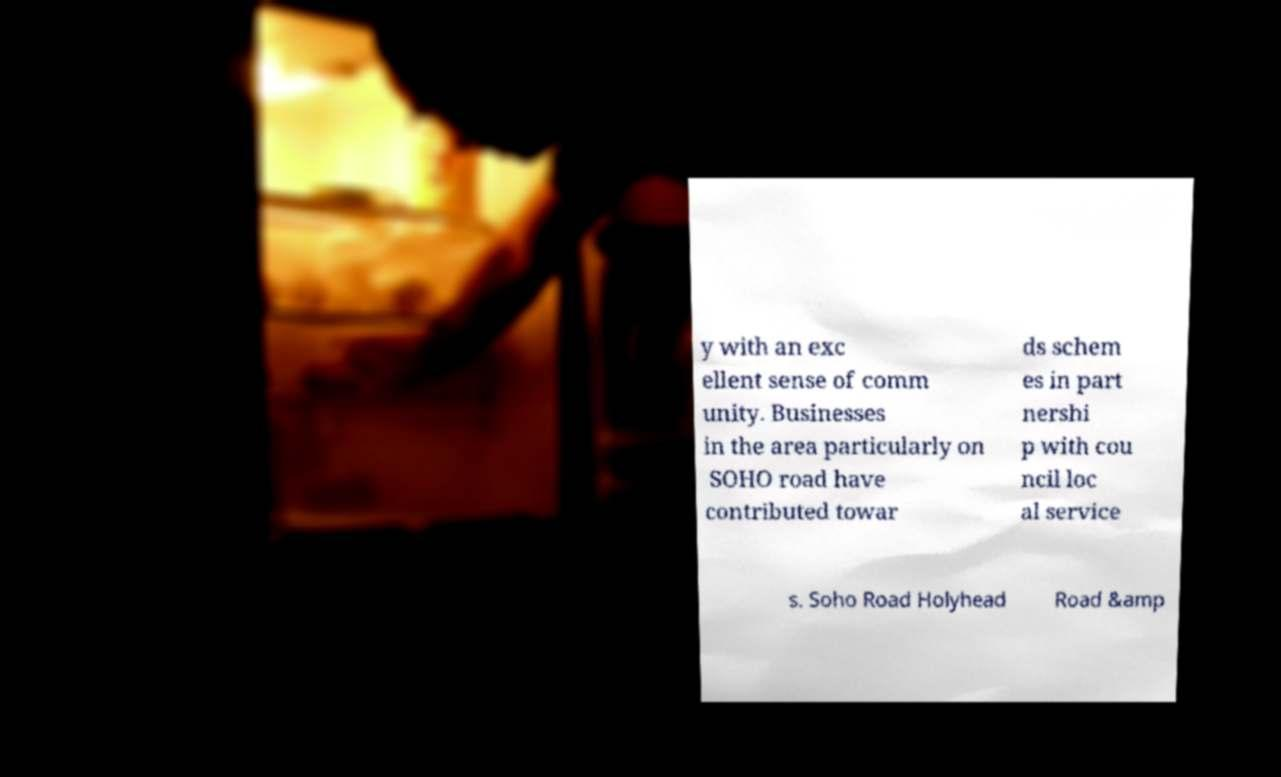Can you read and provide the text displayed in the image?This photo seems to have some interesting text. Can you extract and type it out for me? y with an exc ellent sense of comm unity. Businesses in the area particularly on SOHO road have contributed towar ds schem es in part nershi p with cou ncil loc al service s. Soho Road Holyhead Road &amp 